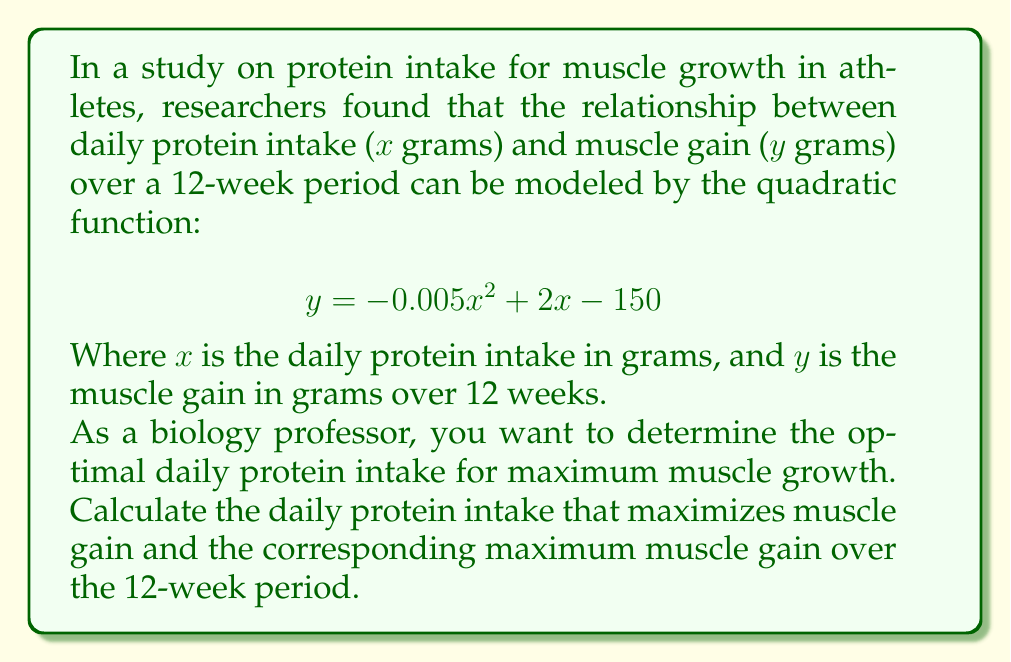Give your solution to this math problem. To find the optimal daily protein intake and maximum muscle gain, we need to follow these steps:

1) The given quadratic function is in the form $y = ax^2 + bx + c$, where:
   $a = -0.005$
   $b = 2$
   $c = -150$

2) For a quadratic function, the x-coordinate of the vertex represents the value of x that maximizes (or minimizes) y. The formula for the x-coordinate of the vertex is:

   $$ x = -\frac{b}{2a} $$

3) Substituting our values:

   $$ x = -\frac{2}{2(-0.005)} = -\frac{2}{-0.01} = 200 $$

4) This means the optimal daily protein intake is 200 grams.

5) To find the maximum muscle gain, we substitute x = 200 into the original function:

   $$ y = -0.005(200)^2 + 2(200) - 150 $$
   $$ y = -0.005(40000) + 400 - 150 $$
   $$ y = -200 + 400 - 150 $$
   $$ y = 50 $$

6) Therefore, the maximum muscle gain over the 12-week period is 50 grams.
Answer: Optimal daily protein intake: 200 grams; Maximum muscle gain: 50 grams 